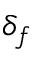<formula> <loc_0><loc_0><loc_500><loc_500>\delta _ { f }</formula> 